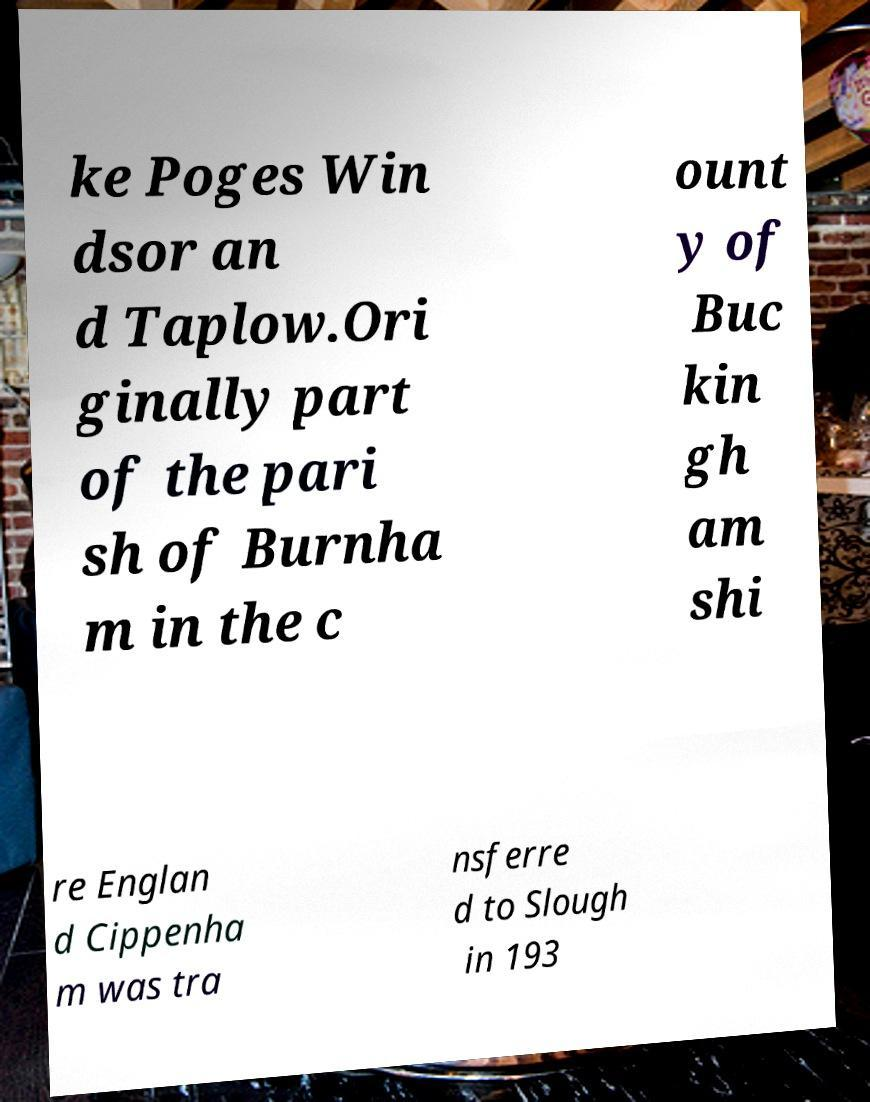There's text embedded in this image that I need extracted. Can you transcribe it verbatim? ke Poges Win dsor an d Taplow.Ori ginally part of the pari sh of Burnha m in the c ount y of Buc kin gh am shi re Englan d Cippenha m was tra nsferre d to Slough in 193 